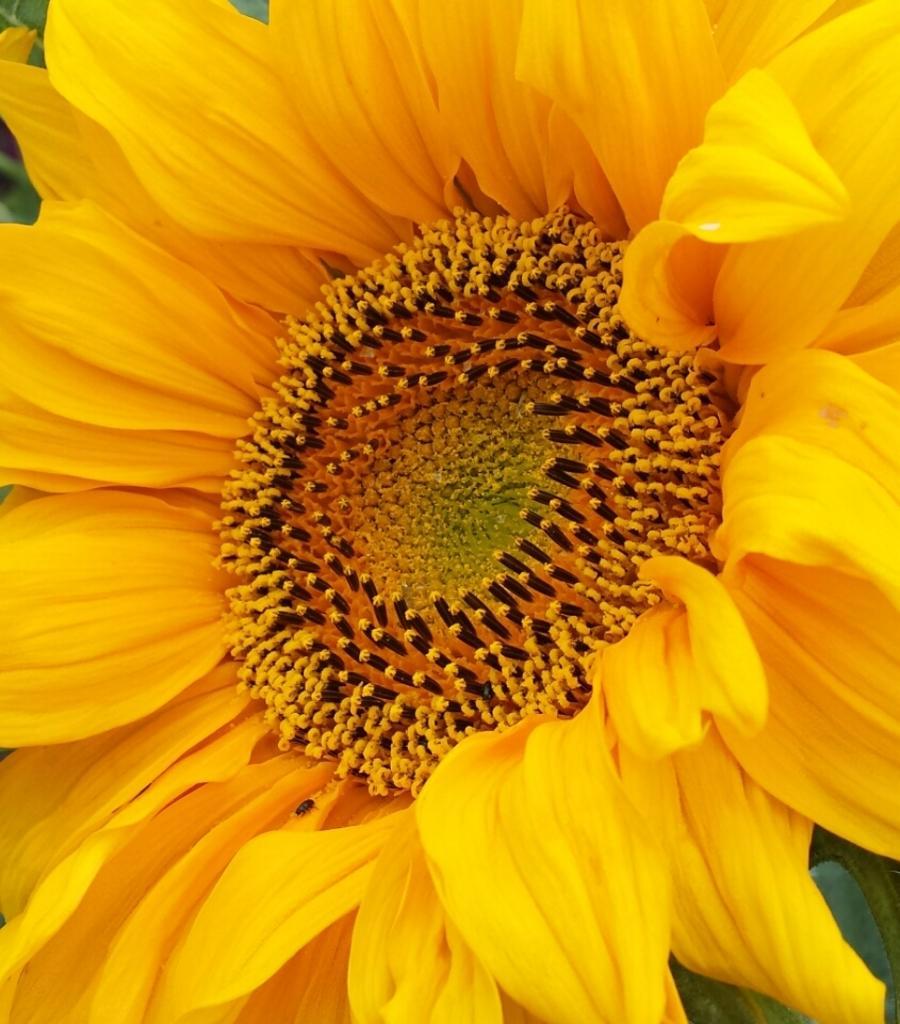Please provide a concise description of this image. In this picture I can observe yellow color flower. There are some buds on the flower. These bugs are in yellow and black color. 